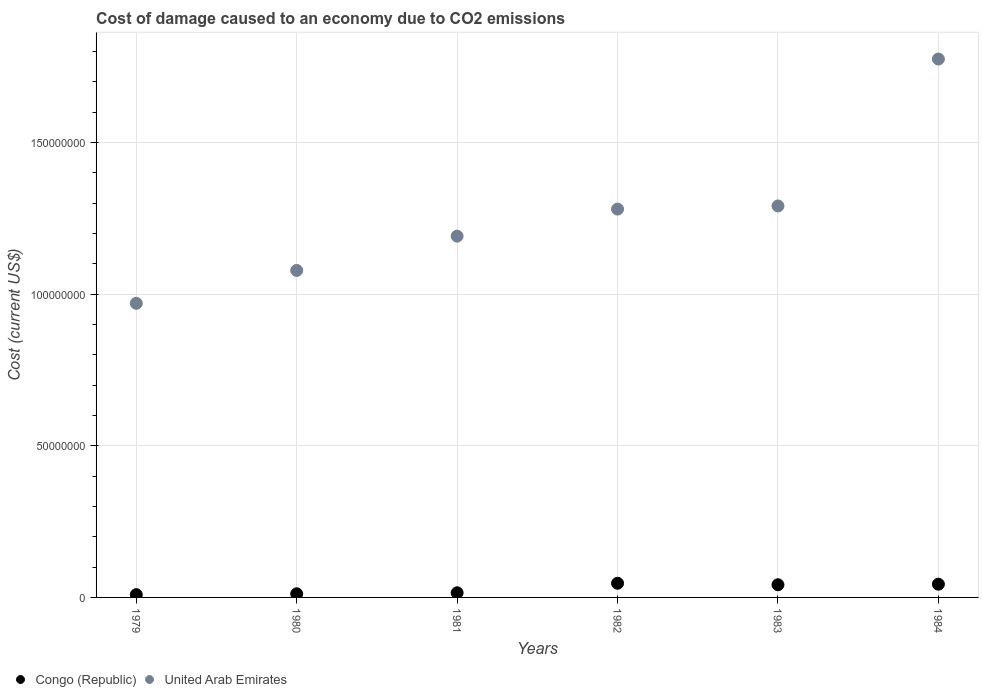Is the number of dotlines equal to the number of legend labels?
Make the answer very short. Yes. What is the cost of damage caused due to CO2 emissisons in United Arab Emirates in 1984?
Give a very brief answer. 1.78e+08. Across all years, what is the maximum cost of damage caused due to CO2 emissisons in Congo (Republic)?
Provide a short and direct response. 4.67e+06. Across all years, what is the minimum cost of damage caused due to CO2 emissisons in United Arab Emirates?
Offer a very short reply. 9.70e+07. In which year was the cost of damage caused due to CO2 emissisons in Congo (Republic) minimum?
Your answer should be very brief. 1979. What is the total cost of damage caused due to CO2 emissisons in United Arab Emirates in the graph?
Make the answer very short. 7.59e+08. What is the difference between the cost of damage caused due to CO2 emissisons in United Arab Emirates in 1982 and that in 1983?
Keep it short and to the point. -1.04e+06. What is the difference between the cost of damage caused due to CO2 emissisons in United Arab Emirates in 1983 and the cost of damage caused due to CO2 emissisons in Congo (Republic) in 1980?
Make the answer very short. 1.28e+08. What is the average cost of damage caused due to CO2 emissisons in United Arab Emirates per year?
Your answer should be very brief. 1.26e+08. In the year 1982, what is the difference between the cost of damage caused due to CO2 emissisons in United Arab Emirates and cost of damage caused due to CO2 emissisons in Congo (Republic)?
Give a very brief answer. 1.23e+08. What is the ratio of the cost of damage caused due to CO2 emissisons in United Arab Emirates in 1982 to that in 1983?
Ensure brevity in your answer.  0.99. Is the cost of damage caused due to CO2 emissisons in United Arab Emirates in 1982 less than that in 1983?
Provide a succinct answer. Yes. Is the difference between the cost of damage caused due to CO2 emissisons in United Arab Emirates in 1980 and 1983 greater than the difference between the cost of damage caused due to CO2 emissisons in Congo (Republic) in 1980 and 1983?
Provide a short and direct response. No. What is the difference between the highest and the second highest cost of damage caused due to CO2 emissisons in Congo (Republic)?
Your answer should be compact. 3.10e+05. What is the difference between the highest and the lowest cost of damage caused due to CO2 emissisons in Congo (Republic)?
Make the answer very short. 3.75e+06. Does the cost of damage caused due to CO2 emissisons in United Arab Emirates monotonically increase over the years?
Your answer should be very brief. Yes. Is the cost of damage caused due to CO2 emissisons in United Arab Emirates strictly greater than the cost of damage caused due to CO2 emissisons in Congo (Republic) over the years?
Your answer should be very brief. Yes. How many dotlines are there?
Ensure brevity in your answer.  2. How many years are there in the graph?
Your response must be concise. 6. Are the values on the major ticks of Y-axis written in scientific E-notation?
Give a very brief answer. No. Does the graph contain any zero values?
Give a very brief answer. No. Where does the legend appear in the graph?
Your answer should be very brief. Bottom left. How many legend labels are there?
Keep it short and to the point. 2. How are the legend labels stacked?
Make the answer very short. Horizontal. What is the title of the graph?
Your answer should be compact. Cost of damage caused to an economy due to CO2 emissions. What is the label or title of the Y-axis?
Your answer should be very brief. Cost (current US$). What is the Cost (current US$) of Congo (Republic) in 1979?
Provide a short and direct response. 9.23e+05. What is the Cost (current US$) in United Arab Emirates in 1979?
Keep it short and to the point. 9.70e+07. What is the Cost (current US$) in Congo (Republic) in 1980?
Provide a short and direct response. 1.19e+06. What is the Cost (current US$) in United Arab Emirates in 1980?
Your answer should be very brief. 1.08e+08. What is the Cost (current US$) of Congo (Republic) in 1981?
Offer a terse response. 1.53e+06. What is the Cost (current US$) of United Arab Emirates in 1981?
Give a very brief answer. 1.19e+08. What is the Cost (current US$) of Congo (Republic) in 1982?
Provide a succinct answer. 4.67e+06. What is the Cost (current US$) in United Arab Emirates in 1982?
Give a very brief answer. 1.28e+08. What is the Cost (current US$) in Congo (Republic) in 1983?
Your response must be concise. 4.18e+06. What is the Cost (current US$) in United Arab Emirates in 1983?
Make the answer very short. 1.29e+08. What is the Cost (current US$) of Congo (Republic) in 1984?
Make the answer very short. 4.36e+06. What is the Cost (current US$) in United Arab Emirates in 1984?
Provide a succinct answer. 1.78e+08. Across all years, what is the maximum Cost (current US$) of Congo (Republic)?
Provide a short and direct response. 4.67e+06. Across all years, what is the maximum Cost (current US$) of United Arab Emirates?
Your answer should be very brief. 1.78e+08. Across all years, what is the minimum Cost (current US$) of Congo (Republic)?
Your response must be concise. 9.23e+05. Across all years, what is the minimum Cost (current US$) in United Arab Emirates?
Your answer should be compact. 9.70e+07. What is the total Cost (current US$) of Congo (Republic) in the graph?
Your response must be concise. 1.69e+07. What is the total Cost (current US$) of United Arab Emirates in the graph?
Offer a terse response. 7.59e+08. What is the difference between the Cost (current US$) of Congo (Republic) in 1979 and that in 1980?
Your response must be concise. -2.66e+05. What is the difference between the Cost (current US$) of United Arab Emirates in 1979 and that in 1980?
Give a very brief answer. -1.09e+07. What is the difference between the Cost (current US$) of Congo (Republic) in 1979 and that in 1981?
Ensure brevity in your answer.  -6.06e+05. What is the difference between the Cost (current US$) in United Arab Emirates in 1979 and that in 1981?
Give a very brief answer. -2.22e+07. What is the difference between the Cost (current US$) of Congo (Republic) in 1979 and that in 1982?
Your answer should be very brief. -3.75e+06. What is the difference between the Cost (current US$) in United Arab Emirates in 1979 and that in 1982?
Provide a succinct answer. -3.11e+07. What is the difference between the Cost (current US$) of Congo (Republic) in 1979 and that in 1983?
Ensure brevity in your answer.  -3.26e+06. What is the difference between the Cost (current US$) in United Arab Emirates in 1979 and that in 1983?
Your response must be concise. -3.21e+07. What is the difference between the Cost (current US$) of Congo (Republic) in 1979 and that in 1984?
Make the answer very short. -3.44e+06. What is the difference between the Cost (current US$) of United Arab Emirates in 1979 and that in 1984?
Give a very brief answer. -8.06e+07. What is the difference between the Cost (current US$) in Congo (Republic) in 1980 and that in 1981?
Make the answer very short. -3.40e+05. What is the difference between the Cost (current US$) in United Arab Emirates in 1980 and that in 1981?
Your answer should be very brief. -1.13e+07. What is the difference between the Cost (current US$) in Congo (Republic) in 1980 and that in 1982?
Offer a very short reply. -3.48e+06. What is the difference between the Cost (current US$) in United Arab Emirates in 1980 and that in 1982?
Provide a short and direct response. -2.02e+07. What is the difference between the Cost (current US$) of Congo (Republic) in 1980 and that in 1983?
Ensure brevity in your answer.  -2.99e+06. What is the difference between the Cost (current US$) in United Arab Emirates in 1980 and that in 1983?
Keep it short and to the point. -2.13e+07. What is the difference between the Cost (current US$) of Congo (Republic) in 1980 and that in 1984?
Offer a terse response. -3.17e+06. What is the difference between the Cost (current US$) of United Arab Emirates in 1980 and that in 1984?
Offer a terse response. -6.97e+07. What is the difference between the Cost (current US$) in Congo (Republic) in 1981 and that in 1982?
Give a very brief answer. -3.15e+06. What is the difference between the Cost (current US$) in United Arab Emirates in 1981 and that in 1982?
Offer a very short reply. -8.93e+06. What is the difference between the Cost (current US$) of Congo (Republic) in 1981 and that in 1983?
Give a very brief answer. -2.65e+06. What is the difference between the Cost (current US$) of United Arab Emirates in 1981 and that in 1983?
Your response must be concise. -9.96e+06. What is the difference between the Cost (current US$) in Congo (Republic) in 1981 and that in 1984?
Provide a short and direct response. -2.84e+06. What is the difference between the Cost (current US$) of United Arab Emirates in 1981 and that in 1984?
Give a very brief answer. -5.84e+07. What is the difference between the Cost (current US$) of Congo (Republic) in 1982 and that in 1983?
Provide a succinct answer. 4.95e+05. What is the difference between the Cost (current US$) of United Arab Emirates in 1982 and that in 1983?
Make the answer very short. -1.04e+06. What is the difference between the Cost (current US$) in Congo (Republic) in 1982 and that in 1984?
Offer a terse response. 3.10e+05. What is the difference between the Cost (current US$) in United Arab Emirates in 1982 and that in 1984?
Provide a short and direct response. -4.95e+07. What is the difference between the Cost (current US$) of Congo (Republic) in 1983 and that in 1984?
Your answer should be compact. -1.85e+05. What is the difference between the Cost (current US$) of United Arab Emirates in 1983 and that in 1984?
Your response must be concise. -4.84e+07. What is the difference between the Cost (current US$) of Congo (Republic) in 1979 and the Cost (current US$) of United Arab Emirates in 1980?
Provide a succinct answer. -1.07e+08. What is the difference between the Cost (current US$) of Congo (Republic) in 1979 and the Cost (current US$) of United Arab Emirates in 1981?
Your answer should be compact. -1.18e+08. What is the difference between the Cost (current US$) of Congo (Republic) in 1979 and the Cost (current US$) of United Arab Emirates in 1982?
Ensure brevity in your answer.  -1.27e+08. What is the difference between the Cost (current US$) in Congo (Republic) in 1979 and the Cost (current US$) in United Arab Emirates in 1983?
Provide a succinct answer. -1.28e+08. What is the difference between the Cost (current US$) in Congo (Republic) in 1979 and the Cost (current US$) in United Arab Emirates in 1984?
Offer a very short reply. -1.77e+08. What is the difference between the Cost (current US$) of Congo (Republic) in 1980 and the Cost (current US$) of United Arab Emirates in 1981?
Offer a very short reply. -1.18e+08. What is the difference between the Cost (current US$) in Congo (Republic) in 1980 and the Cost (current US$) in United Arab Emirates in 1982?
Offer a terse response. -1.27e+08. What is the difference between the Cost (current US$) in Congo (Republic) in 1980 and the Cost (current US$) in United Arab Emirates in 1983?
Your response must be concise. -1.28e+08. What is the difference between the Cost (current US$) in Congo (Republic) in 1980 and the Cost (current US$) in United Arab Emirates in 1984?
Keep it short and to the point. -1.76e+08. What is the difference between the Cost (current US$) of Congo (Republic) in 1981 and the Cost (current US$) of United Arab Emirates in 1982?
Your answer should be compact. -1.27e+08. What is the difference between the Cost (current US$) in Congo (Republic) in 1981 and the Cost (current US$) in United Arab Emirates in 1983?
Offer a very short reply. -1.28e+08. What is the difference between the Cost (current US$) of Congo (Republic) in 1981 and the Cost (current US$) of United Arab Emirates in 1984?
Ensure brevity in your answer.  -1.76e+08. What is the difference between the Cost (current US$) in Congo (Republic) in 1982 and the Cost (current US$) in United Arab Emirates in 1983?
Offer a very short reply. -1.24e+08. What is the difference between the Cost (current US$) in Congo (Republic) in 1982 and the Cost (current US$) in United Arab Emirates in 1984?
Ensure brevity in your answer.  -1.73e+08. What is the difference between the Cost (current US$) in Congo (Republic) in 1983 and the Cost (current US$) in United Arab Emirates in 1984?
Ensure brevity in your answer.  -1.73e+08. What is the average Cost (current US$) in Congo (Republic) per year?
Offer a very short reply. 2.81e+06. What is the average Cost (current US$) in United Arab Emirates per year?
Offer a terse response. 1.26e+08. In the year 1979, what is the difference between the Cost (current US$) in Congo (Republic) and Cost (current US$) in United Arab Emirates?
Your answer should be very brief. -9.61e+07. In the year 1980, what is the difference between the Cost (current US$) in Congo (Republic) and Cost (current US$) in United Arab Emirates?
Make the answer very short. -1.07e+08. In the year 1981, what is the difference between the Cost (current US$) in Congo (Republic) and Cost (current US$) in United Arab Emirates?
Keep it short and to the point. -1.18e+08. In the year 1982, what is the difference between the Cost (current US$) in Congo (Republic) and Cost (current US$) in United Arab Emirates?
Make the answer very short. -1.23e+08. In the year 1983, what is the difference between the Cost (current US$) in Congo (Republic) and Cost (current US$) in United Arab Emirates?
Keep it short and to the point. -1.25e+08. In the year 1984, what is the difference between the Cost (current US$) of Congo (Republic) and Cost (current US$) of United Arab Emirates?
Offer a terse response. -1.73e+08. What is the ratio of the Cost (current US$) of Congo (Republic) in 1979 to that in 1980?
Your answer should be compact. 0.78. What is the ratio of the Cost (current US$) of United Arab Emirates in 1979 to that in 1980?
Give a very brief answer. 0.9. What is the ratio of the Cost (current US$) in Congo (Republic) in 1979 to that in 1981?
Provide a succinct answer. 0.6. What is the ratio of the Cost (current US$) in United Arab Emirates in 1979 to that in 1981?
Offer a terse response. 0.81. What is the ratio of the Cost (current US$) in Congo (Republic) in 1979 to that in 1982?
Make the answer very short. 0.2. What is the ratio of the Cost (current US$) of United Arab Emirates in 1979 to that in 1982?
Offer a terse response. 0.76. What is the ratio of the Cost (current US$) of Congo (Republic) in 1979 to that in 1983?
Offer a terse response. 0.22. What is the ratio of the Cost (current US$) of United Arab Emirates in 1979 to that in 1983?
Your answer should be compact. 0.75. What is the ratio of the Cost (current US$) of Congo (Republic) in 1979 to that in 1984?
Provide a succinct answer. 0.21. What is the ratio of the Cost (current US$) in United Arab Emirates in 1979 to that in 1984?
Ensure brevity in your answer.  0.55. What is the ratio of the Cost (current US$) of Congo (Republic) in 1980 to that in 1981?
Provide a short and direct response. 0.78. What is the ratio of the Cost (current US$) of United Arab Emirates in 1980 to that in 1981?
Ensure brevity in your answer.  0.91. What is the ratio of the Cost (current US$) of Congo (Republic) in 1980 to that in 1982?
Give a very brief answer. 0.25. What is the ratio of the Cost (current US$) in United Arab Emirates in 1980 to that in 1982?
Your answer should be compact. 0.84. What is the ratio of the Cost (current US$) of Congo (Republic) in 1980 to that in 1983?
Offer a very short reply. 0.28. What is the ratio of the Cost (current US$) of United Arab Emirates in 1980 to that in 1983?
Provide a succinct answer. 0.84. What is the ratio of the Cost (current US$) of Congo (Republic) in 1980 to that in 1984?
Offer a very short reply. 0.27. What is the ratio of the Cost (current US$) in United Arab Emirates in 1980 to that in 1984?
Give a very brief answer. 0.61. What is the ratio of the Cost (current US$) of Congo (Republic) in 1981 to that in 1982?
Keep it short and to the point. 0.33. What is the ratio of the Cost (current US$) of United Arab Emirates in 1981 to that in 1982?
Your answer should be very brief. 0.93. What is the ratio of the Cost (current US$) of Congo (Republic) in 1981 to that in 1983?
Make the answer very short. 0.37. What is the ratio of the Cost (current US$) of United Arab Emirates in 1981 to that in 1983?
Keep it short and to the point. 0.92. What is the ratio of the Cost (current US$) in Congo (Republic) in 1981 to that in 1984?
Offer a terse response. 0.35. What is the ratio of the Cost (current US$) of United Arab Emirates in 1981 to that in 1984?
Provide a succinct answer. 0.67. What is the ratio of the Cost (current US$) in Congo (Republic) in 1982 to that in 1983?
Your answer should be compact. 1.12. What is the ratio of the Cost (current US$) in Congo (Republic) in 1982 to that in 1984?
Give a very brief answer. 1.07. What is the ratio of the Cost (current US$) in United Arab Emirates in 1982 to that in 1984?
Ensure brevity in your answer.  0.72. What is the ratio of the Cost (current US$) in Congo (Republic) in 1983 to that in 1984?
Your answer should be compact. 0.96. What is the ratio of the Cost (current US$) in United Arab Emirates in 1983 to that in 1984?
Provide a short and direct response. 0.73. What is the difference between the highest and the second highest Cost (current US$) of Congo (Republic)?
Offer a terse response. 3.10e+05. What is the difference between the highest and the second highest Cost (current US$) in United Arab Emirates?
Offer a terse response. 4.84e+07. What is the difference between the highest and the lowest Cost (current US$) of Congo (Republic)?
Offer a very short reply. 3.75e+06. What is the difference between the highest and the lowest Cost (current US$) in United Arab Emirates?
Make the answer very short. 8.06e+07. 